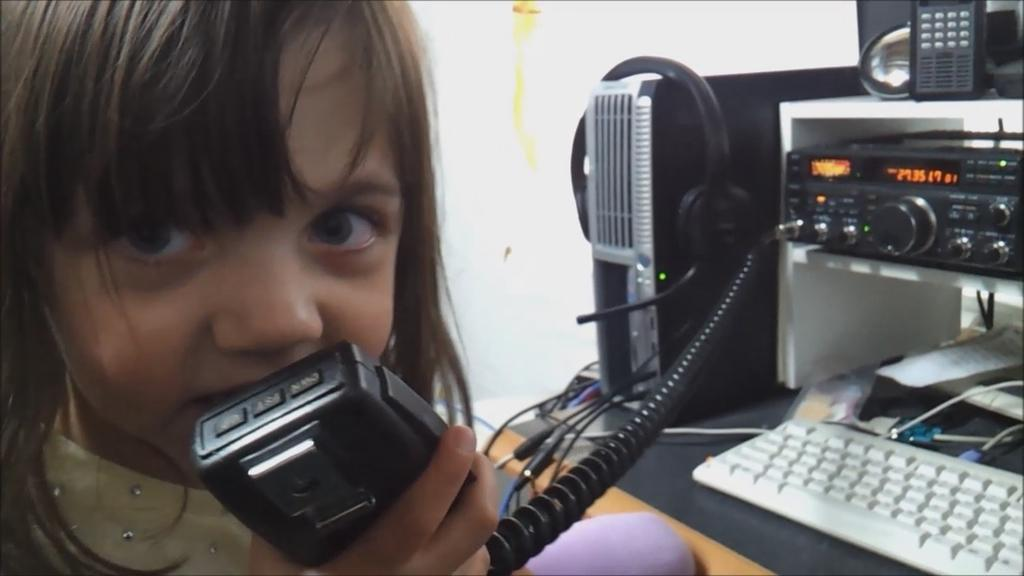Who is present in the image? There is a girl in the image. What is the girl holding in the image? The girl is holding a walkie talkie. What other objects can be seen in the image? There is a keyboard and a headset in the image. What type of items are present in the image? There are electronic devices in the image. What can be seen in the background of the image? There is a wall in the background of the image. What type of weather can be seen in the image? There is no indication of weather in the image; it is an indoor scene. What type of cabbage is being used as a prop in the image? There is no cabbage present in the image. Is the girl playing volleyball in the image? There is no indication of volleyball or any sports activity in the image. 